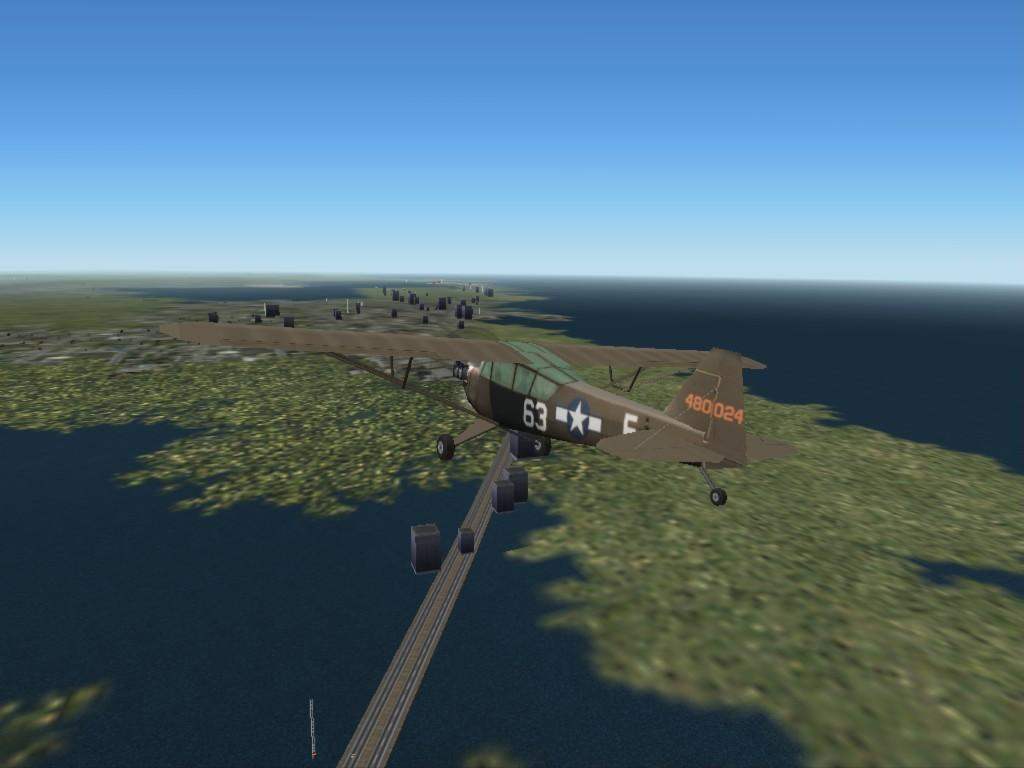<image>
Give a short and clear explanation of the subsequent image. A small, brown airplane with the number 63 on the side flying in the sky. 